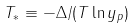<formula> <loc_0><loc_0><loc_500><loc_500>T _ { \ast } \equiv - \Delta / ( T \ln y _ { p } )</formula> 